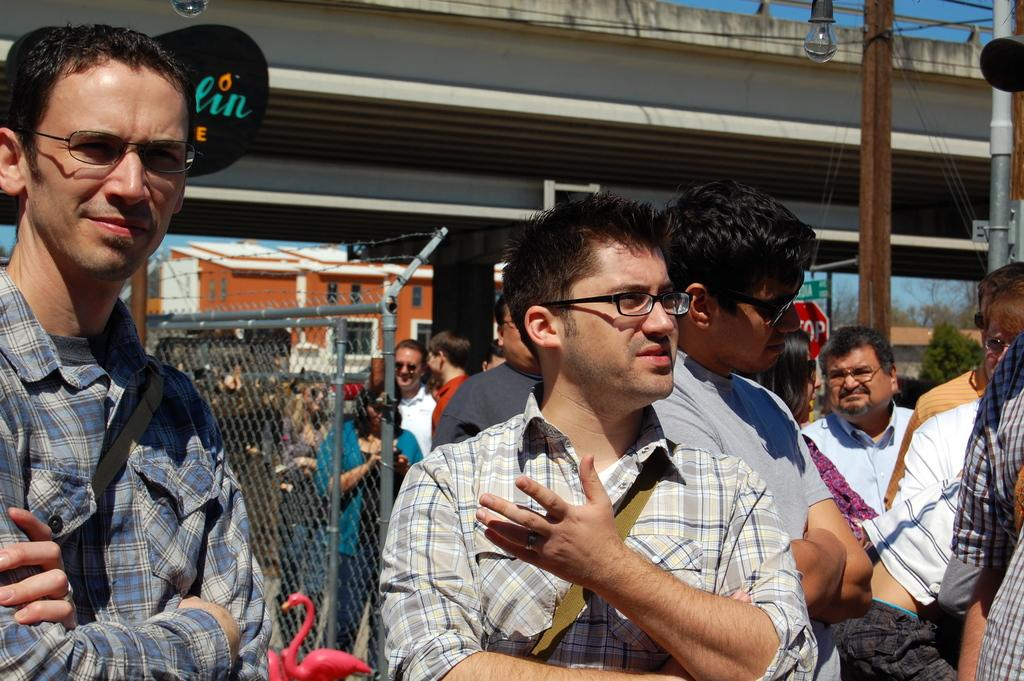How many people are in the image? There is a group of persons standing in the image. What can be seen in the background of the image? There is a bridge, houses, and trees in the background of the image. What type of stamp can be seen on the partner's hand in the image? There is no partner or stamp present in the image. 